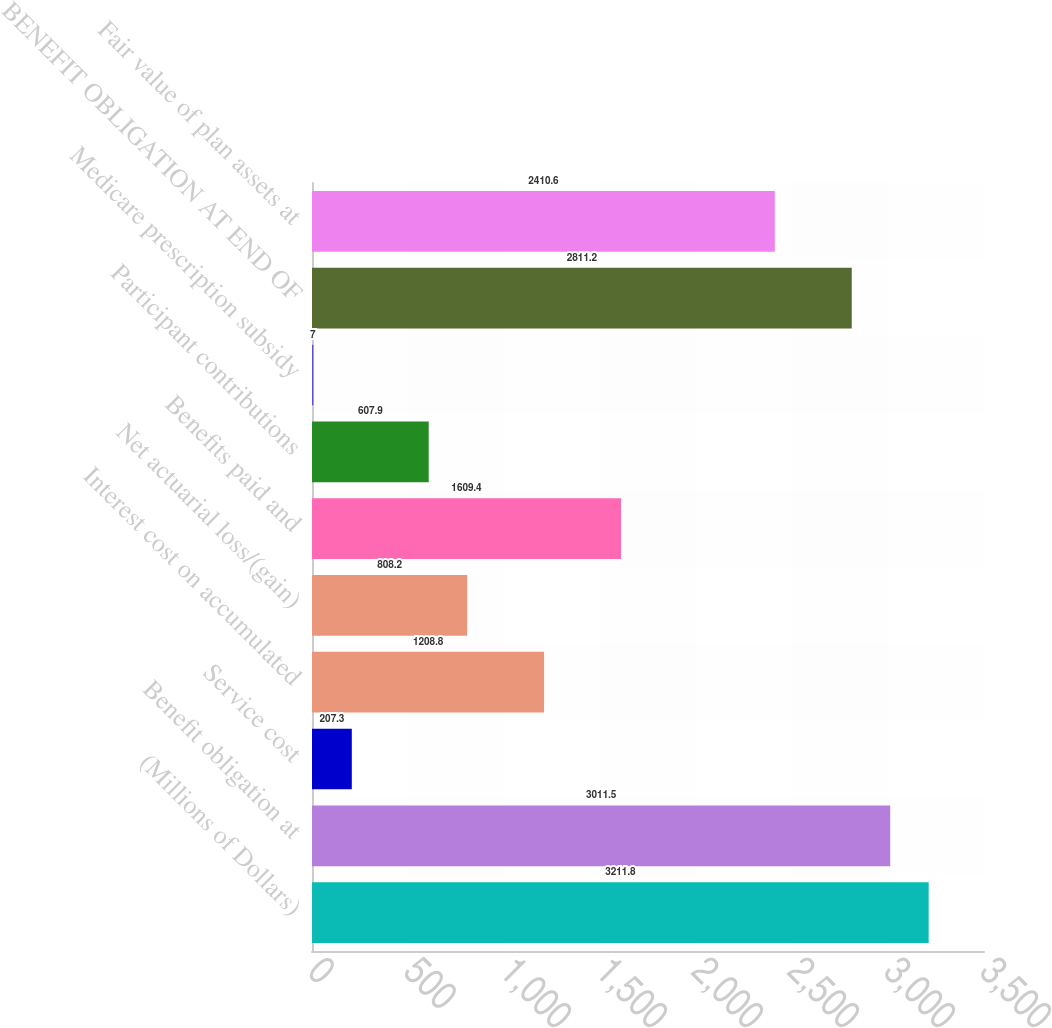Convert chart to OTSL. <chart><loc_0><loc_0><loc_500><loc_500><bar_chart><fcel>(Millions of Dollars)<fcel>Benefit obligation at<fcel>Service cost<fcel>Interest cost on accumulated<fcel>Net actuarial loss/(gain)<fcel>Benefits paid and<fcel>Participant contributions<fcel>Medicare prescription subsidy<fcel>BENEFIT OBLIGATION AT END OF<fcel>Fair value of plan assets at<nl><fcel>3211.8<fcel>3011.5<fcel>207.3<fcel>1208.8<fcel>808.2<fcel>1609.4<fcel>607.9<fcel>7<fcel>2811.2<fcel>2410.6<nl></chart> 